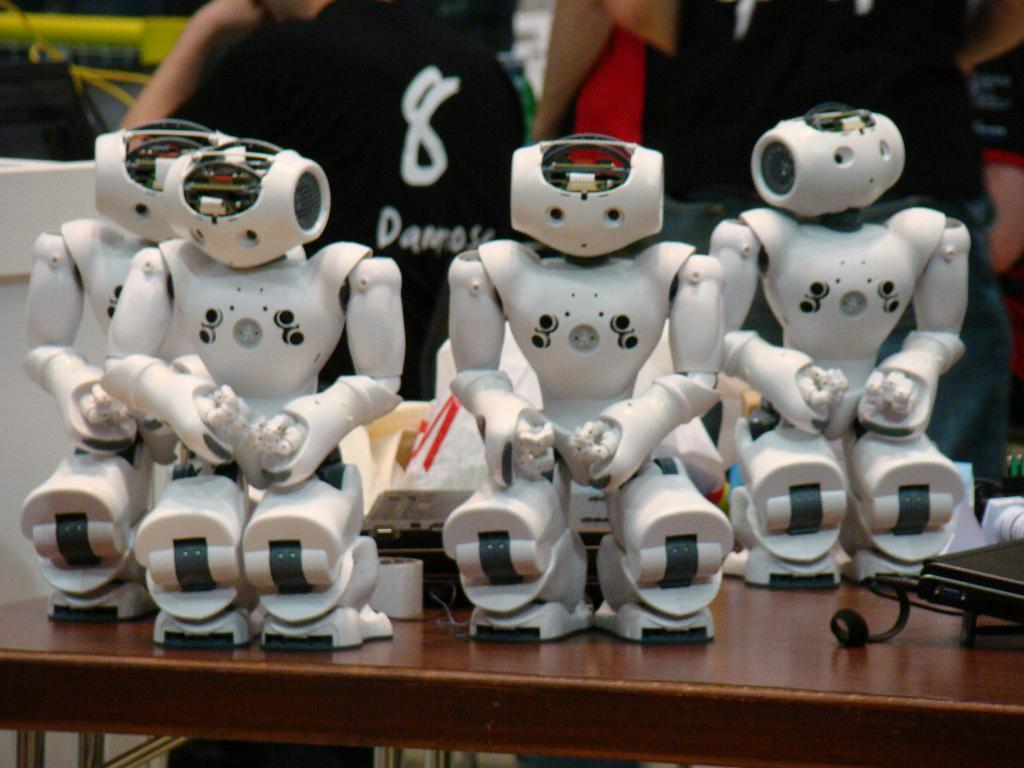How many robots are present in the image? There are four robots in the image. What else can be seen on the table besides the robots? There are other gadgets on the table. What is the main piece of furniture in the image? The table is visible in the image. Can you describe the people behind the table? Unfortunately, the facts provided do not give any information about the people behind the table. What type of whistle can be heard in the image? There is no whistle present in the image, and therefore no sound can be heard. How many symbols of peace are visible in the image? There is no mention of peace symbols in the image, so it is impossible to determine their presence or amount. 